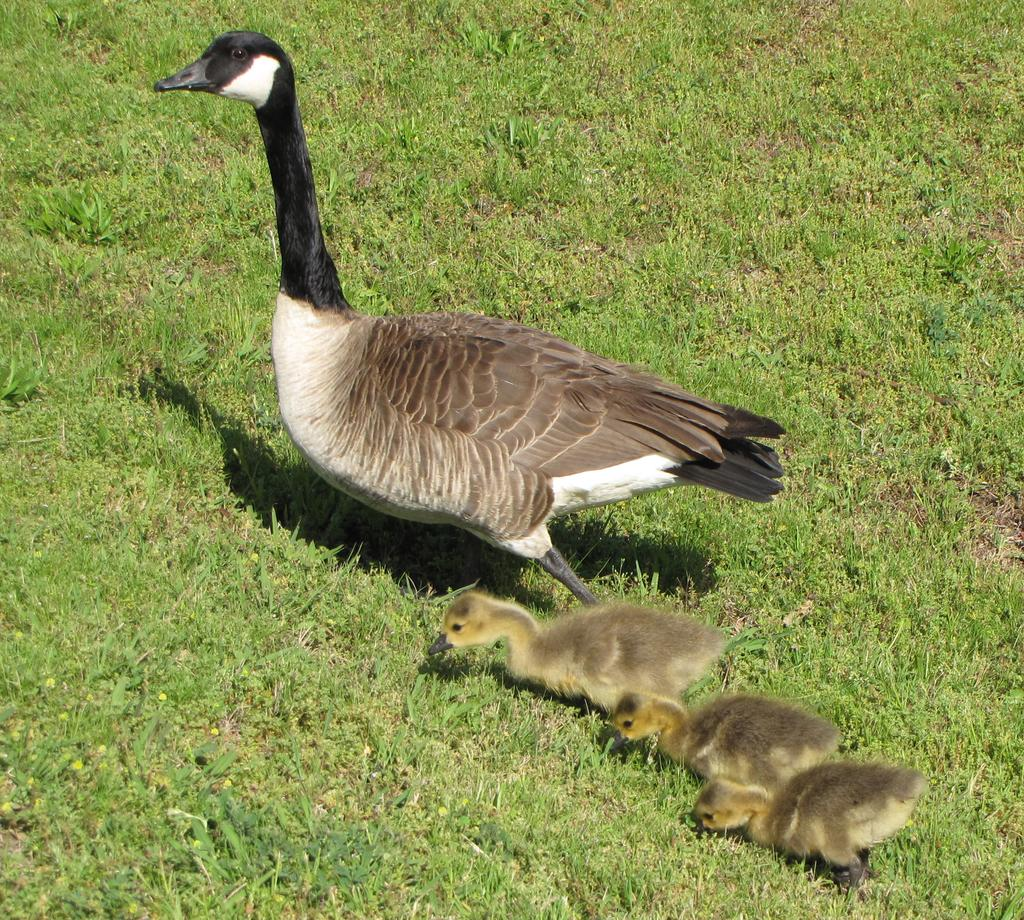What type of animals can be seen in the image? There are birds in the image. What colors are the birds in the image? The birds are in brown, black, and white colors. What surface are the birds walking on? The birds are walking on the grass. What is the color of the grass in the image? The grass is green in color. Can you tell me how many chairs are visible in the image? There are no chairs present in the image; it features birds walking on green grass. What type of tooth can be seen in the image? There are no teeth present in the image; it features birds walking on green grass. 